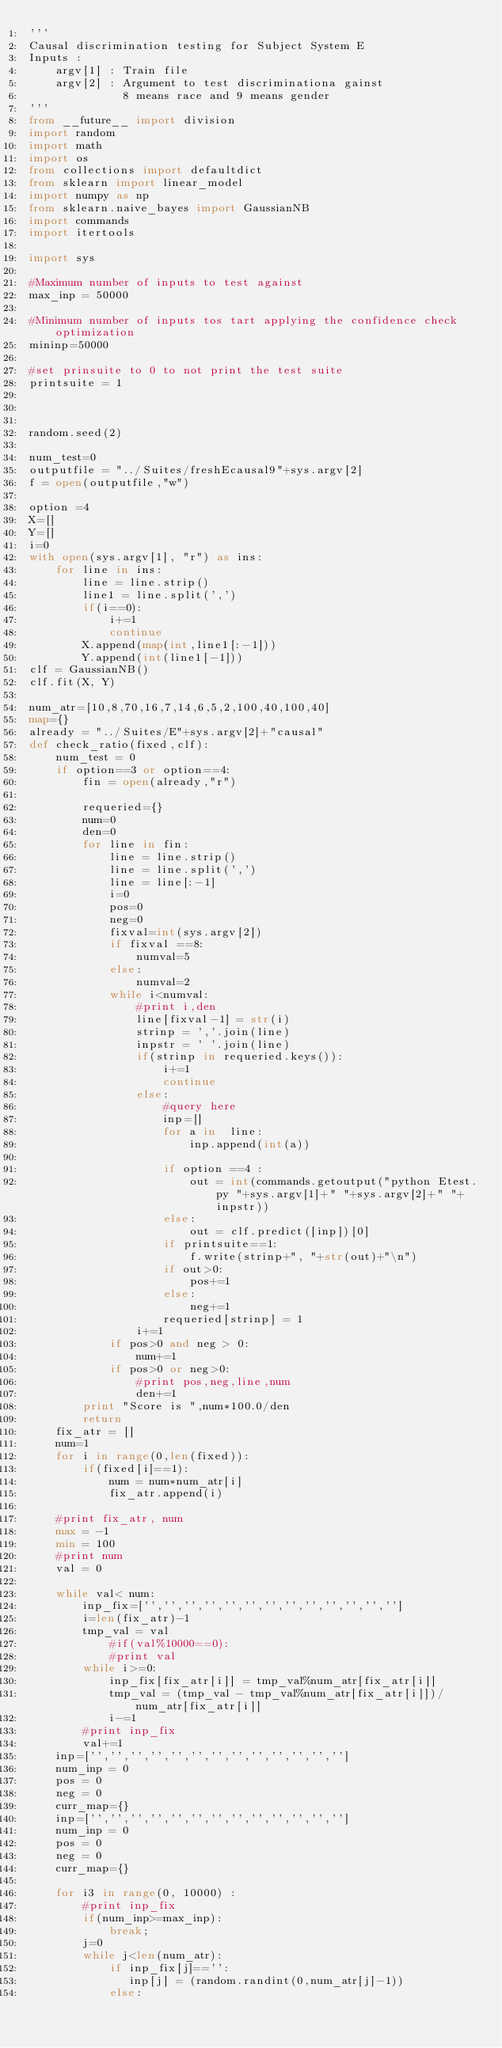Convert code to text. <code><loc_0><loc_0><loc_500><loc_500><_Python_>'''
Causal discrimination testing for Subject System E
Inputs :
    argv[1] : Train file
    argv[2] : Argument to test discriminationa gainst
              8 means race and 9 means gender
'''
from __future__ import division
import random
import math
import os
from collections import defaultdict
from sklearn import linear_model
import numpy as np
from sklearn.naive_bayes import GaussianNB
import commands
import itertools

import sys

#Maximum number of inputs to test against
max_inp = 50000

#Minimum number of inputs tos tart applying the confidence check optimization
mininp=50000

#set prinsuite to 0 to not print the test suite
printsuite = 1



random.seed(2)

num_test=0
outputfile = "../Suites/freshEcausal9"+sys.argv[2]
f = open(outputfile,"w")

option =4
X=[]
Y=[]
i=0
with open(sys.argv[1], "r") as ins:
    for line in ins:
        line = line.strip()
        line1 = line.split(',')
        if(i==0):
            i+=1
            continue
        X.append(map(int,line1[:-1]))
        Y.append(int(line1[-1]))
clf = GaussianNB()
clf.fit(X, Y)

num_atr=[10,8,70,16,7,14,6,5,2,100,40,100,40]
map={}
already = "../Suites/E"+sys.argv[2]+"causal"
def check_ratio(fixed,clf):
    num_test = 0
    if option==3 or option==4:
        fin = open(already,"r")

        requeried={}
        num=0
        den=0
        for line in fin:
            line = line.strip()
            line = line.split(',')
            line = line[:-1]
            i=0
            pos=0
            neg=0
            fixval=int(sys.argv[2])
            if fixval ==8:
                numval=5
            else:
                numval=2
            while i<numval:
                #print i,den
                line[fixval-1] = str(i)
                strinp = ','.join(line)
                inpstr = ' '.join(line)
                if(strinp in requeried.keys()):
                    i+=1
                    continue
                else:
                    #query here
                    inp=[]
                    for a in  line:
                        inp.append(int(a))
                    
                    if option ==4 :   
                        out = int(commands.getoutput("python Etest.py "+sys.argv[1]+" "+sys.argv[2]+" "+inpstr))
                    else:
                        out = clf.predict([inp])[0]
                    if printsuite==1:
                        f.write(strinp+", "+str(out)+"\n")
                    if out>0:
                        pos+=1
                    else:
                        neg+=1
                    requeried[strinp] = 1
                i+=1
            if pos>0 and neg > 0:
                num+=1
            if pos>0 or neg>0:
                #print pos,neg,line,num
                den+=1
        print "Score is ",num*100.0/den
        return
    fix_atr = []
    num=1
    for i in range(0,len(fixed)):
        if(fixed[i]==1):
            num = num*num_atr[i]
            fix_atr.append(i)

    #print fix_atr, num
    max = -1
    min = 100
    #print num
    val = 0

    while val< num:
        inp_fix=['','','','','','','','','','','','','']
        i=len(fix_atr)-1
        tmp_val = val
            #if(val%10000==0):
            #print val
        while i>=0:
            inp_fix[fix_atr[i]] = tmp_val%num_atr[fix_atr[i]]
            tmp_val = (tmp_val - tmp_val%num_atr[fix_atr[i]])/num_atr[fix_atr[i]]
            i-=1
        #print inp_fix
        val+=1
    inp=['','','','','','','','','','','','','']
    num_inp = 0
    pos = 0
    neg = 0
    curr_map={}
    inp=['','','','','','','','','','','','','']
    num_inp = 0
    pos = 0
    neg = 0
    curr_map={}

    for i3 in range(0, 10000) :
        #print inp_fix
        if(num_inp>=max_inp):
            break;
        j=0
        while j<len(num_atr):
            if inp_fix[j]=='':
               inp[j] = (random.randint(0,num_atr[j]-1))
            else:</code> 